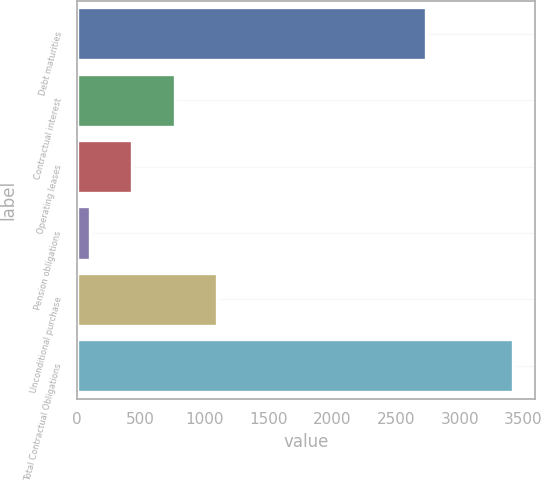Convert chart to OTSL. <chart><loc_0><loc_0><loc_500><loc_500><bar_chart><fcel>Debt maturities<fcel>Contractual interest<fcel>Operating leases<fcel>Pension obligations<fcel>Unconditional purchase<fcel>Total Contractual Obligations<nl><fcel>2738<fcel>766.8<fcel>435.4<fcel>104<fcel>1098.2<fcel>3418<nl></chart> 